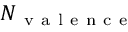Convert formula to latex. <formula><loc_0><loc_0><loc_500><loc_500>N _ { v a l e n c e }</formula> 